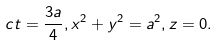Convert formula to latex. <formula><loc_0><loc_0><loc_500><loc_500>c t = \frac { 3 a } { 4 } , x ^ { 2 } + y ^ { 2 } = a ^ { 2 } , z = 0 .</formula> 